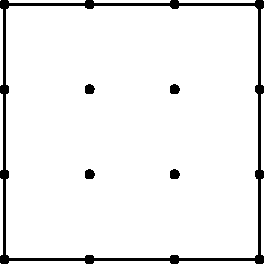In your latest literary adventure, you stumble upon a curious geometric puzzle hidden within the pages. The puzzle presents a 4x4 grid of dots, reminiscent of a chessboard shrunk to a quarter of its size. Your task is to determine the number of unique triangles that can be formed by connecting these dots. How many distinct triangles can you create, and how might this relate to the intricate plot structures you often analyze in your book reviews? Let's approach this step-by-step, much like we would dissect a complex narrative:

1) First, we need to calculate the total number of dots:
   $4 \times 4 = 16$ dots

2) To form a triangle, we need to choose 3 dots from these 16. This is a combination problem, represented as $\binom{16}{3}$ or $C(16,3)$.

3) The formula for this combination is:
   $$\binom{16}{3} = \frac{16!}{3!(16-3)!} = \frac{16!}{3!13!}$$

4) Calculating this:
   $$\frac{16 \times 15 \times 14}{3 \times 2 \times 1} = 560$$

5) However, this counts all possible triangles, including degenerate ones (where three points are in a straight line).

6) To count degenerate triangles:
   - Horizontal lines: 4 rows, each with $\binom{4}{3} = 4$ triangles
   - Vertical lines: 4 columns, each with $\binom{4}{3} = 4$ triangles
   - Diagonal lines: 2 main diagonals, each with $\binom{4}{3} = 4$ triangles
   - Other diagonals: 4 in each direction, each with $\binom{3}{3} = 1$ triangle

7) Total degenerate triangles:
   $(4 + 4) \times 4 + 2 \times 4 + 4 \times 2 = 40$

8) Therefore, the number of unique, non-degenerate triangles is:
   $560 - 40 = 520$

This process of elimination to find the true number of unique triangles mirrors how we often need to sift through red herrings and false leads in mystery novels to uncover the real plot.
Answer: 520 unique triangles 